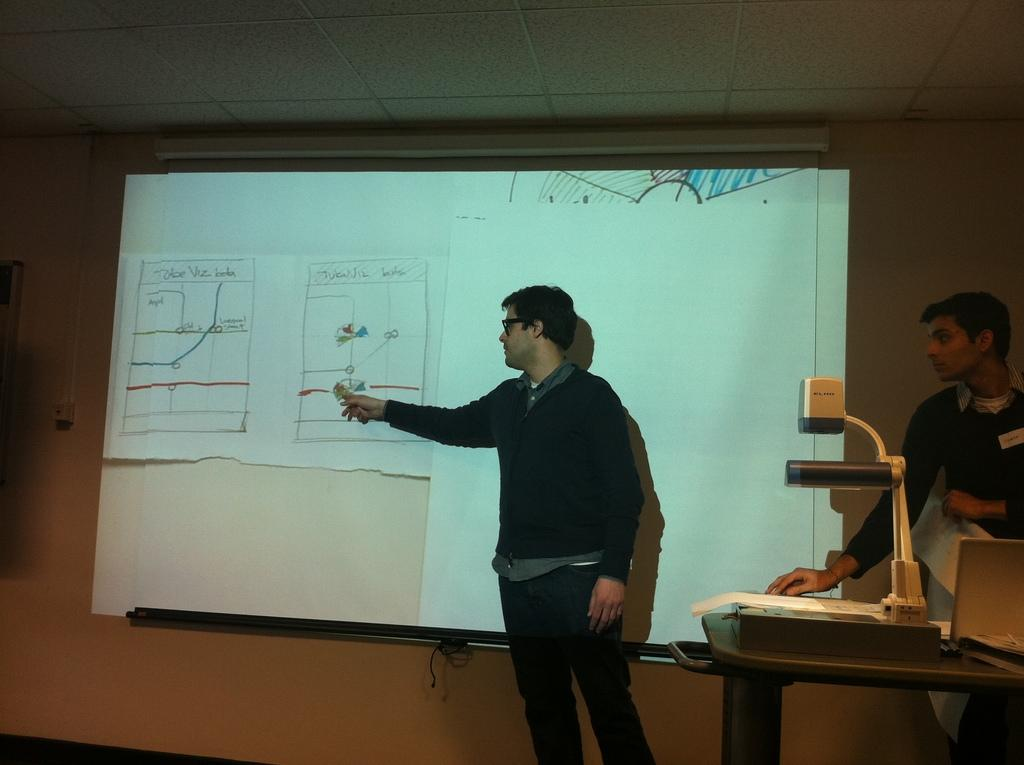What is the main subject of the image? There is a person standing at the wall in the center of the image. What is on the wall in the image? Charts are visible on the wall. What can be seen on the right side of the image? There is a table and lights on the right side of the image. Are there any other people in the image? Yes, there is another person on the right side of the image. What type of prose is the person reading in the image? There is no indication in the image that the person is reading any prose. Can you tell me how many aunts are present in the image? There are no aunts present in the image. 